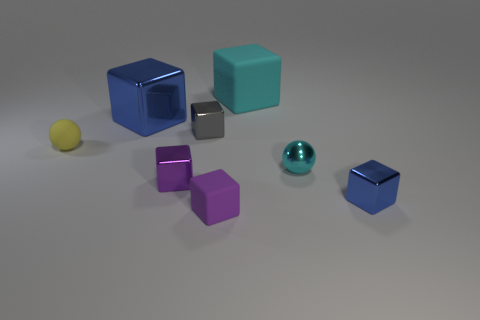Subtract all blue cylinders. How many purple blocks are left? 2 Subtract all cyan blocks. How many blocks are left? 5 Subtract all gray blocks. How many blocks are left? 5 Add 1 small cubes. How many objects exist? 9 Subtract all green blocks. Subtract all blue cylinders. How many blocks are left? 6 Subtract all cubes. How many objects are left? 2 Subtract 0 blue cylinders. How many objects are left? 8 Subtract all gray things. Subtract all cyan metal cylinders. How many objects are left? 7 Add 3 gray objects. How many gray objects are left? 4 Add 7 big green rubber blocks. How many big green rubber blocks exist? 7 